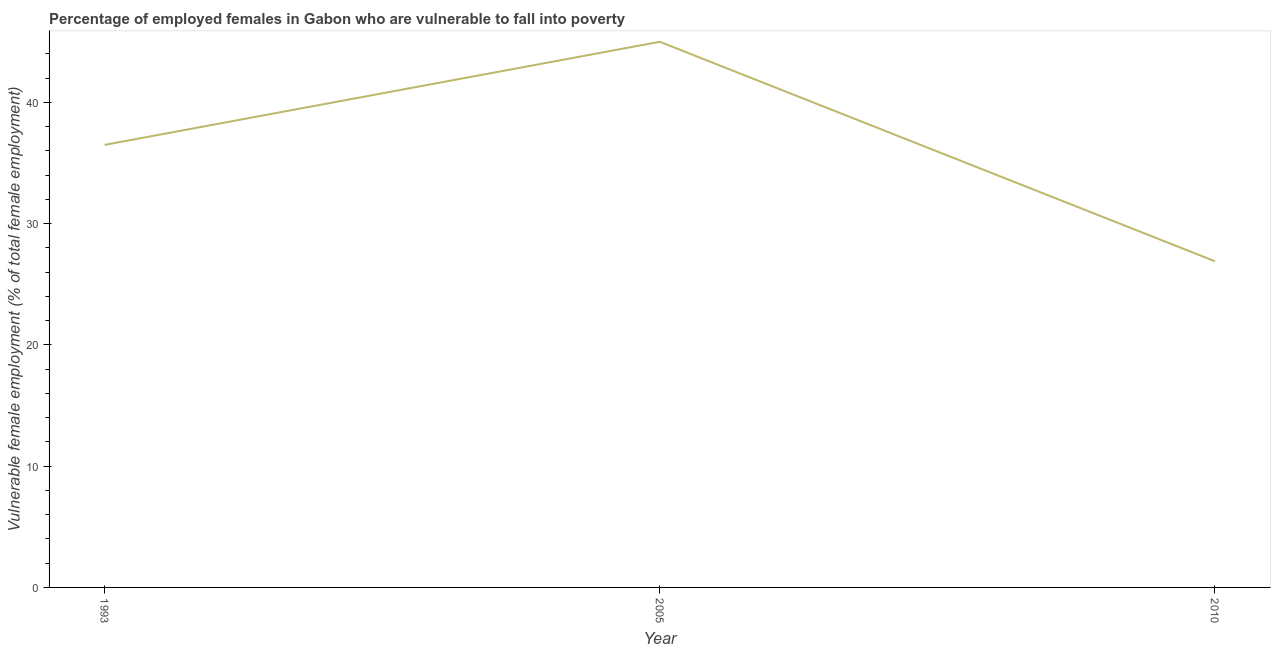Across all years, what is the minimum percentage of employed females who are vulnerable to fall into poverty?
Your response must be concise. 26.9. In which year was the percentage of employed females who are vulnerable to fall into poverty maximum?
Give a very brief answer. 2005. What is the sum of the percentage of employed females who are vulnerable to fall into poverty?
Ensure brevity in your answer.  108.4. What is the difference between the percentage of employed females who are vulnerable to fall into poverty in 2005 and 2010?
Make the answer very short. 18.1. What is the average percentage of employed females who are vulnerable to fall into poverty per year?
Offer a terse response. 36.13. What is the median percentage of employed females who are vulnerable to fall into poverty?
Give a very brief answer. 36.5. What is the ratio of the percentage of employed females who are vulnerable to fall into poverty in 1993 to that in 2010?
Offer a very short reply. 1.36. Is the percentage of employed females who are vulnerable to fall into poverty in 1993 less than that in 2010?
Offer a terse response. No. What is the difference between the highest and the second highest percentage of employed females who are vulnerable to fall into poverty?
Provide a short and direct response. 8.5. What is the difference between the highest and the lowest percentage of employed females who are vulnerable to fall into poverty?
Your response must be concise. 18.1. In how many years, is the percentage of employed females who are vulnerable to fall into poverty greater than the average percentage of employed females who are vulnerable to fall into poverty taken over all years?
Keep it short and to the point. 2. Does the percentage of employed females who are vulnerable to fall into poverty monotonically increase over the years?
Your answer should be compact. No. How many years are there in the graph?
Provide a succinct answer. 3. Are the values on the major ticks of Y-axis written in scientific E-notation?
Provide a succinct answer. No. Does the graph contain grids?
Your answer should be compact. No. What is the title of the graph?
Your response must be concise. Percentage of employed females in Gabon who are vulnerable to fall into poverty. What is the label or title of the X-axis?
Offer a terse response. Year. What is the label or title of the Y-axis?
Provide a succinct answer. Vulnerable female employment (% of total female employment). What is the Vulnerable female employment (% of total female employment) of 1993?
Provide a succinct answer. 36.5. What is the Vulnerable female employment (% of total female employment) in 2010?
Offer a terse response. 26.9. What is the ratio of the Vulnerable female employment (% of total female employment) in 1993 to that in 2005?
Your answer should be very brief. 0.81. What is the ratio of the Vulnerable female employment (% of total female employment) in 1993 to that in 2010?
Your response must be concise. 1.36. What is the ratio of the Vulnerable female employment (% of total female employment) in 2005 to that in 2010?
Your answer should be very brief. 1.67. 